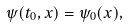<formula> <loc_0><loc_0><loc_500><loc_500>\psi ( t _ { 0 } , x ) = \psi _ { 0 } ( x ) ,</formula> 